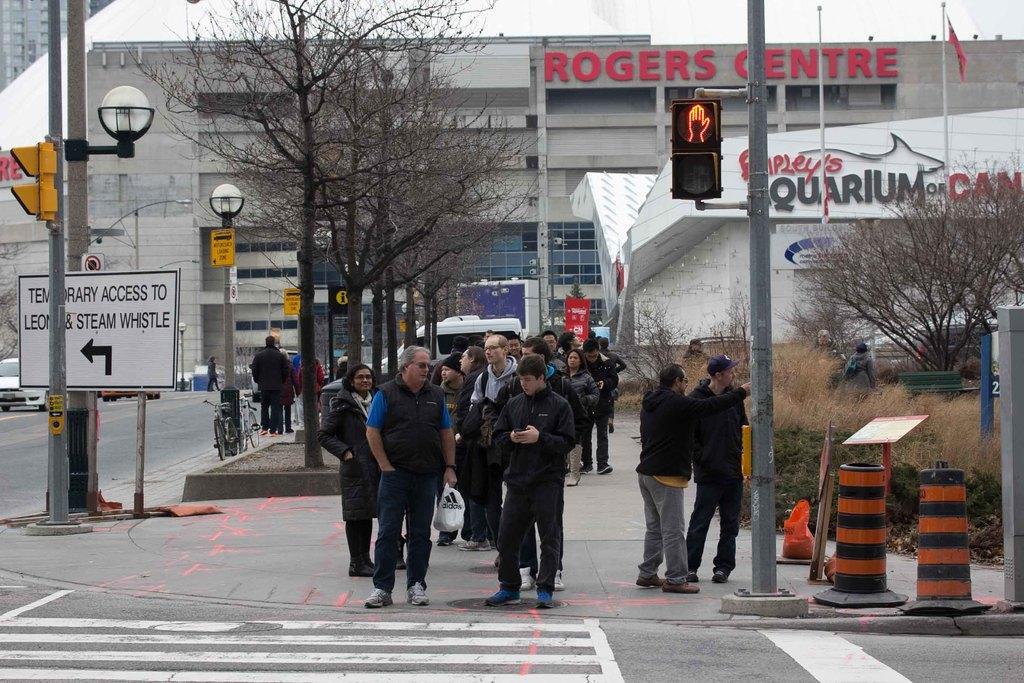Describe this image in one or two sentences. In this image I can see number of people are standing. I can see most of them are wearing jackets. I can also see roads and on this road I can see few white lines. In the background I can see few poles, few lights, few signal lights, number of trees, grass, few buildings, a flag and I can see something is written on these boards. I can also see few bicycles over there. 